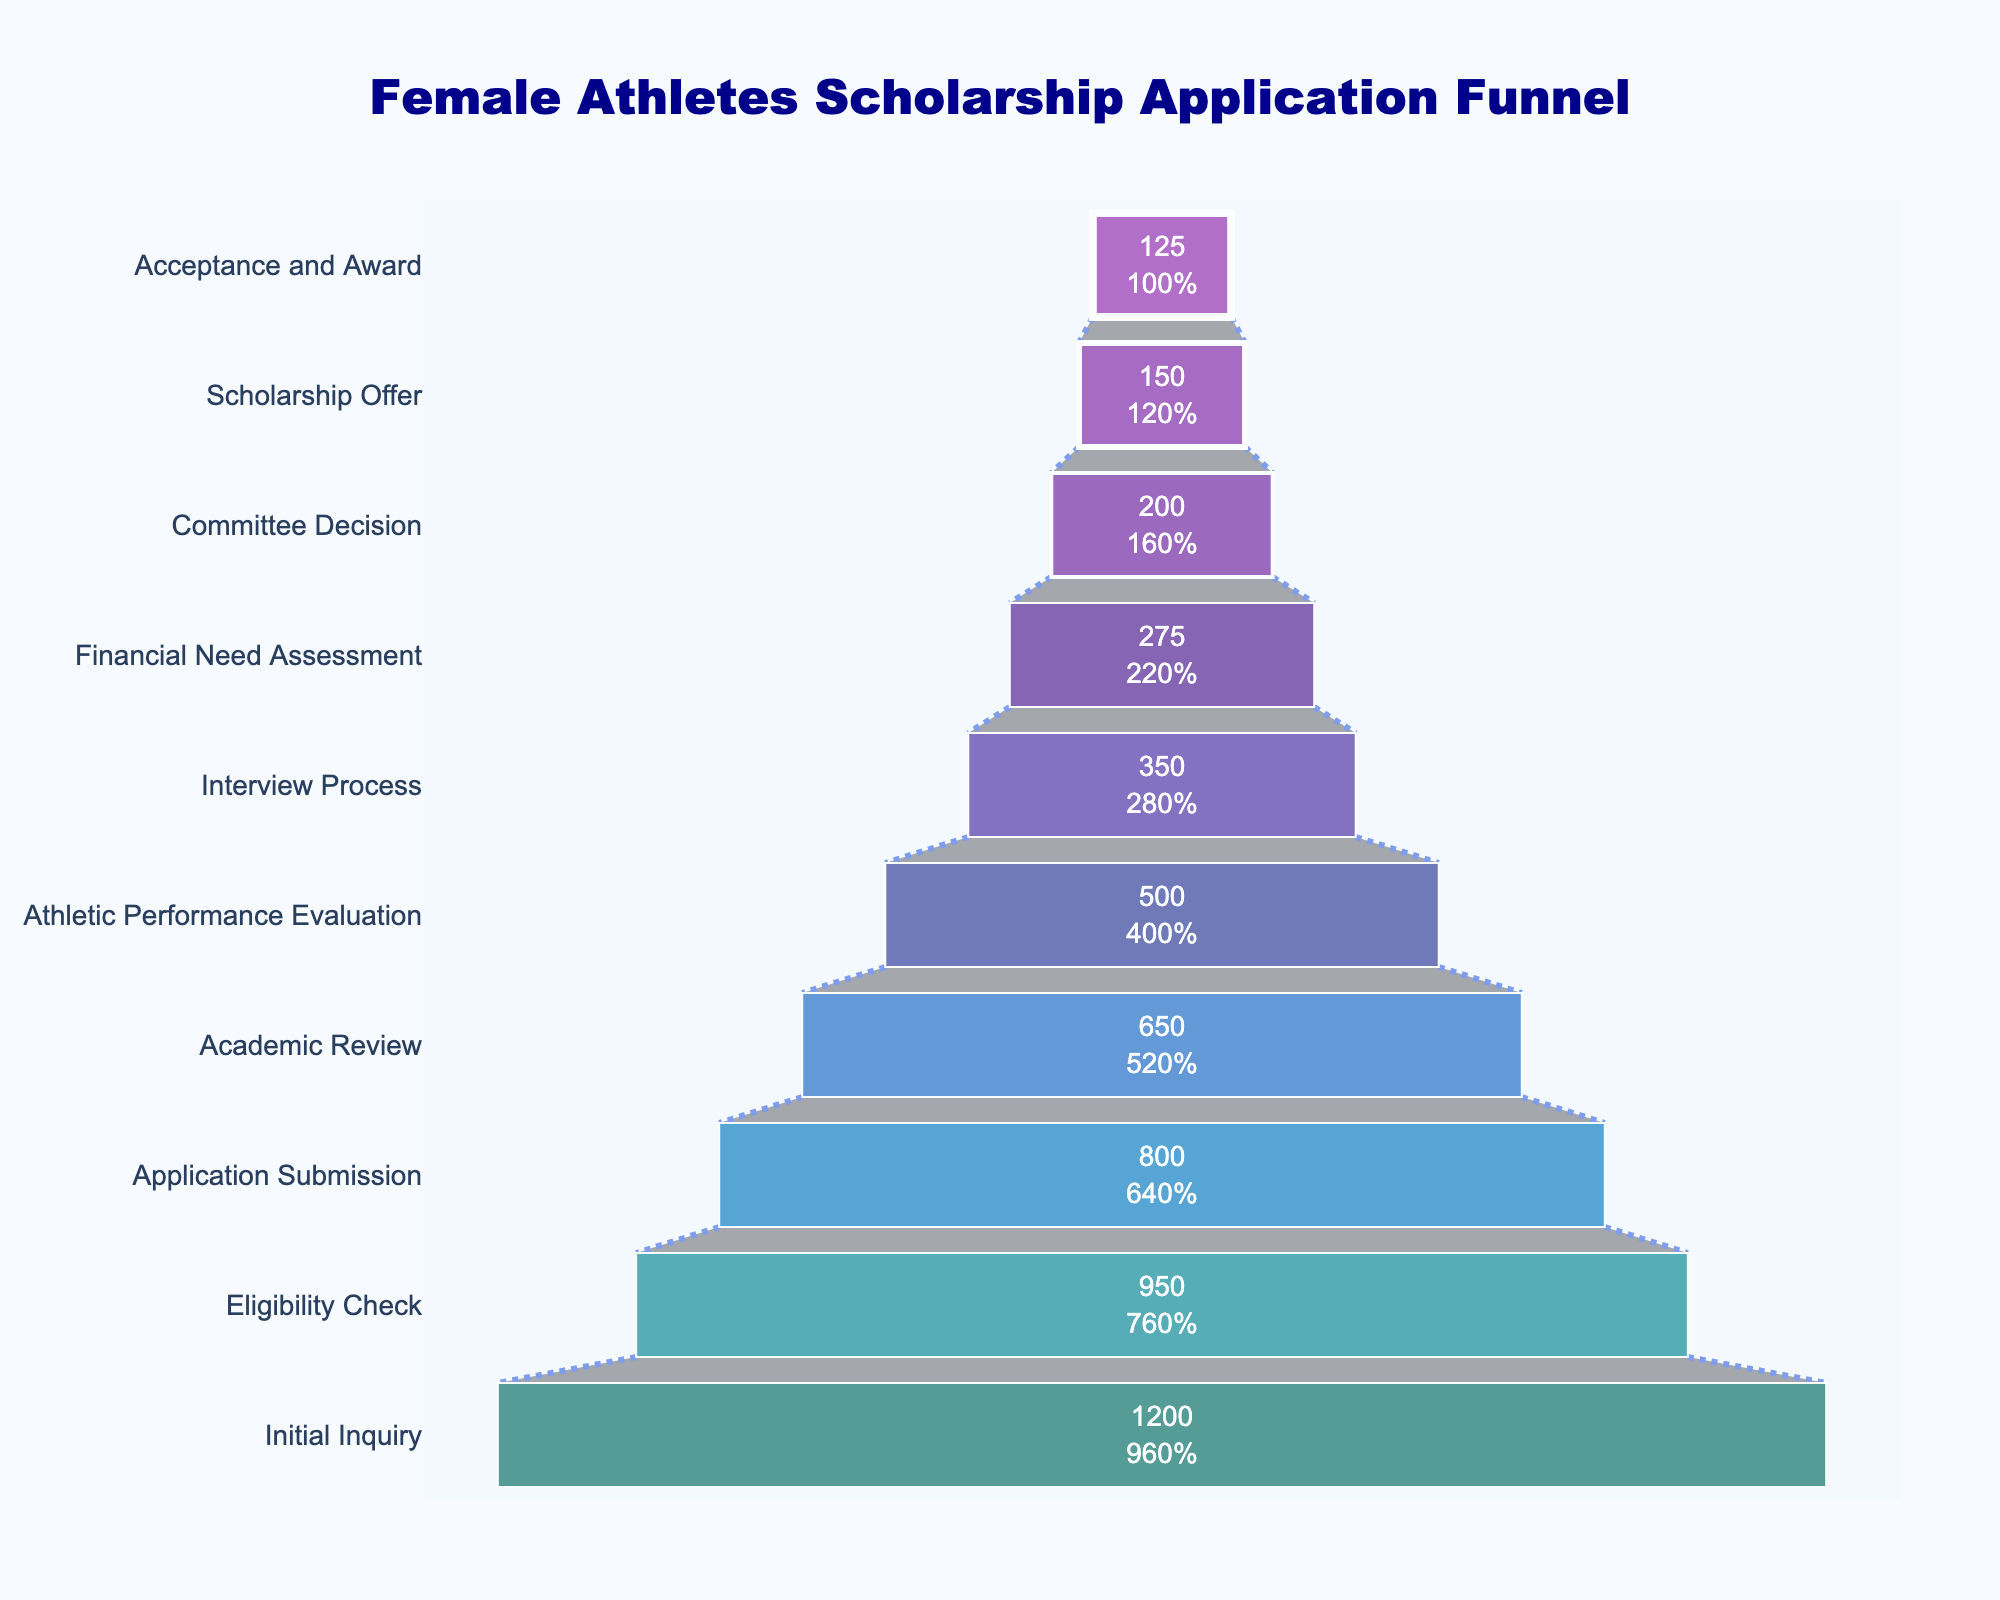What is the title of the funnel chart? The title is located at the top of the chart and it describes what the chart is about.
Answer: Female Athletes Scholarship Application Funnel How many stages are in the scholarship application process? You can determine this by counting the different stages listed on the funnel chart.
Answer: 10 What percentage of applicants proceed from the Initial Inquiry stage to the Eligibility Check stage? The funnel chart displays the percentage of applicants that make it from one stage to the next.
Answer: 79.2% How many applicants are successfully awarded the scholarship? The final stage of the funnel represents those who received the scholarship. The number inside this segment tells us the answer.
Answer: 125 What is the difference between the number of applicants at the Initial Inquiry stage and the number that reach the Application Submission stage? Subtract the number of applicants at the Application Submission stage from those at the Initial Inquiry stage (1200 - 800 = 400).
Answer: 400 Which stage has the largest drop in the number of applicants compared to the previous stage? To find this, calculate the differences between successive stages and identify the largest drop. (950-800, 800-650, 650-500, 500-350, 350-275, 275-200, 200-150, 150-125). The highest value points to the largest drop.
Answer: Interview Process stage How many stages see fewer than half of the initial applicants proceed? Identify stages that have less than 600 applicants (half of 1200).
Answer: 6 stages What is the ratio of applicants who pass the Academic Review stage to those who proceed to the Athletic Performance Evaluation stage? Divide the number of applicants at the Athletic Performance Evaluation stage by the number at the Academic Review stage (500/650).
Answer: ~0.77 How does the number of applicants change from the Committee Decision stage to the Scholarship Offer stage? Subtract the number of applicants at the Scholarship Offer stage from those at the Committee Decision stage (200 - 150 = 50).
Answer: Decreases by 50 What stage follows the Eligibility Check? Look at the layout and sequence of the stages in the funnel chart. After Eligibility Check, the next stage is Application Submission.
Answer: Application Submission 